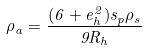Convert formula to latex. <formula><loc_0><loc_0><loc_500><loc_500>\rho _ { a } = \frac { ( 6 + e _ { h } ^ { 2 } ) s _ { p } \rho _ { s } } { 9 R _ { h } }</formula> 